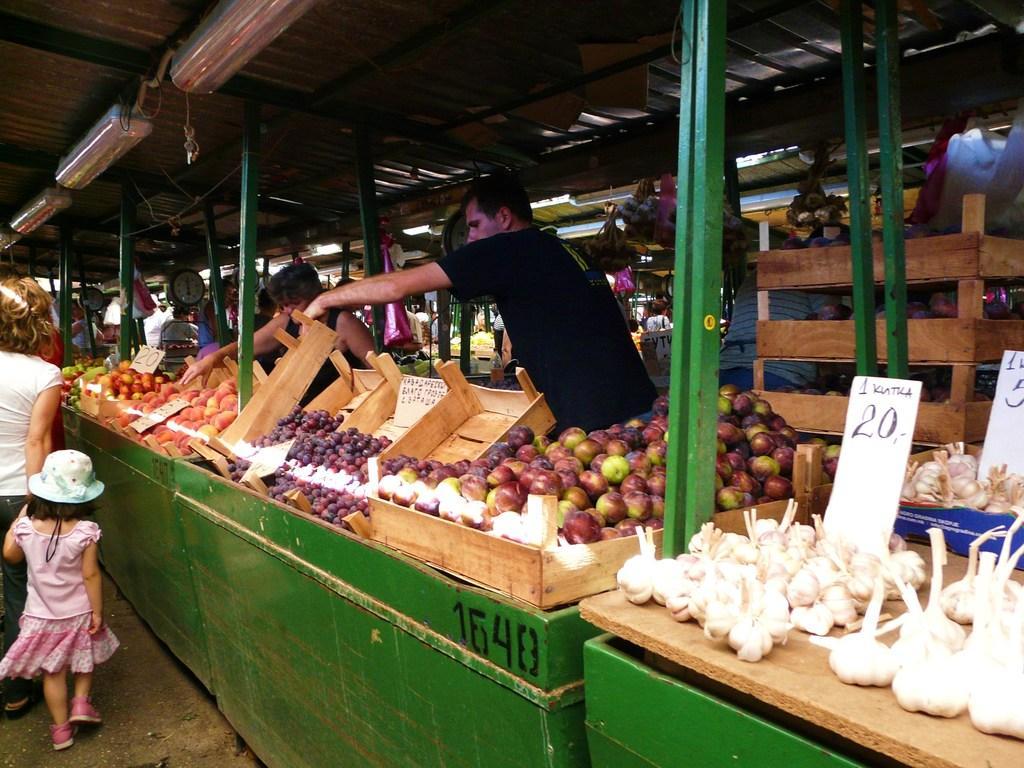Describe this image in one or two sentences. In the image we can see there are people standing on the ground near the stalls. There are fruits and vegetables kept in the basket and there are shopkeepers standing in the stalls. 